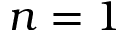Convert formula to latex. <formula><loc_0><loc_0><loc_500><loc_500>n = 1</formula> 